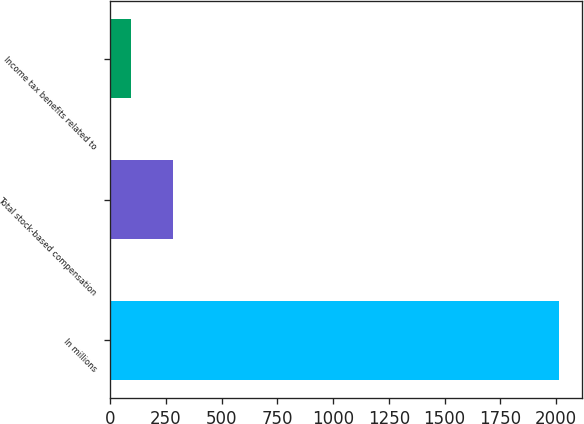Convert chart to OTSL. <chart><loc_0><loc_0><loc_500><loc_500><bar_chart><fcel>In millions<fcel>Total stock-based compensation<fcel>Income tax benefits related to<nl><fcel>2014<fcel>284.2<fcel>92<nl></chart> 